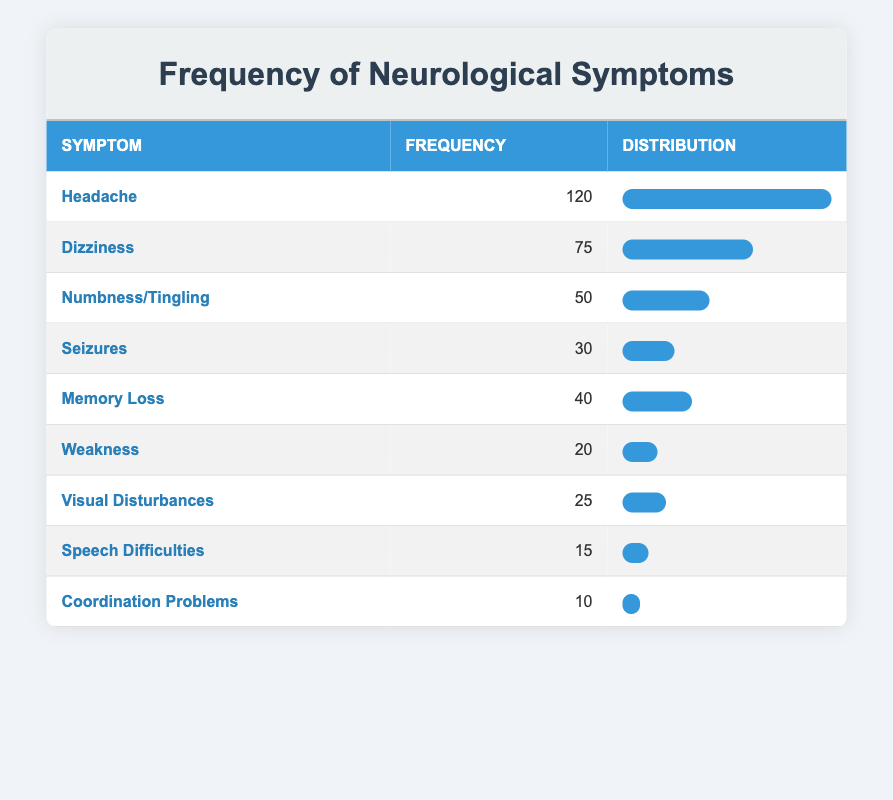What is the frequency of headaches presented by patients? The table shows that the frequency of headaches is listed as 120.
Answer: 120 Which neurological symptom has the lowest frequency? By reviewing the frequency column, coordination problems have the lowest frequency at 10.
Answer: Coordination Problems What is the total frequency of all symptoms listed? Adding the frequencies: 120 (headache) + 75 (dizziness) + 50 (numbness/tingling) + 30 (seizures) + 40 (memory loss) + 20 (weakness) + 25 (visual disturbances) + 15 (speech difficulties) + 10 (coordination problems) gives a total of 120 + 75 + 50 + 30 + 40 + 20 + 25 + 15 + 10 =  375.
Answer: 375 What percentage of the total frequency does memory loss represent? First, find memory loss frequency, which is 40. Then calculate the percentage: (40 / 375) * 100 = 10.67%.
Answer: 10.67% Is the frequency of seizures greater than that of visual disturbances? Seizures have a frequency of 30, and visual disturbances have a frequency of 25. Since 30 > 25, the answer is yes.
Answer: Yes What is the average frequency of all listed neurological symptoms? Calculate the average by dividing the total frequency (375) by the number of symptoms (9): 375 / 9 = 41.67.
Answer: 41.67 Which two symptoms have frequencies that sum up to more than 100? Headache (120) and dizziness (75) sum to 195. Headache and memory loss (120 + 40 = 160) also exceed 100. So, headache and dizziness, and headache and memory loss qualify.
Answer: Headache and Dizziness How many symptoms have a frequency greater than 50? By examining the frequency column, the symptoms greater than 50 are headache (120) and dizziness (75). This totals to 2 symptoms.
Answer: 2 